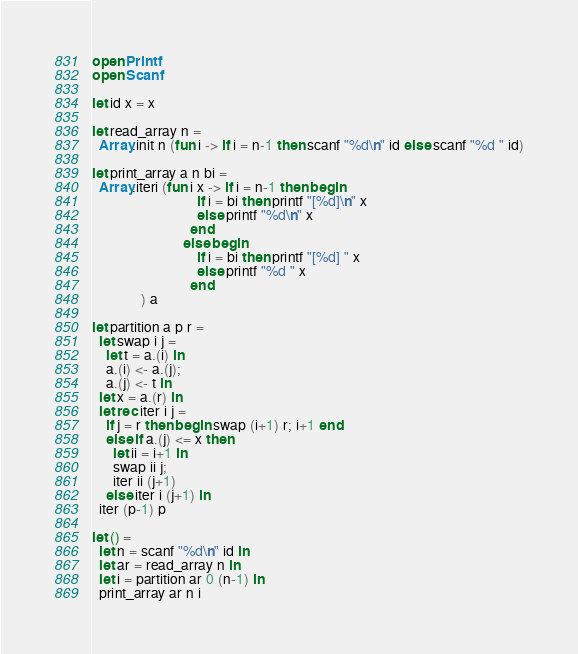<code> <loc_0><loc_0><loc_500><loc_500><_OCaml_>open Printf
open Scanf

let id x = x

let read_array n =
  Array.init n (fun i -> if i = n-1 then scanf "%d\n" id else scanf "%d " id)

let print_array a n bi =
  Array.iteri (fun i x -> if i = n-1 then begin
                              if i = bi then printf "[%d]\n" x
                              else printf "%d\n" x
                            end             
                          else begin
                              if i = bi then printf "[%d] " x
                              else printf "%d " x
                            end
              ) a

let partition a p r =
  let swap i j =
    let t = a.(i) in
    a.(i) <- a.(j);
    a.(j) <- t in
  let x = a.(r) in
  let rec iter i j =
    if j = r then begin swap (i+1) r; i+1 end
    else if a.(j) <= x then
      let ii = i+1 in
      swap ii j;
      iter ii (j+1)
    else iter i (j+1) in
  iter (p-1) p
  
let () =
  let n = scanf "%d\n" id in
  let ar = read_array n in
  let i = partition ar 0 (n-1) in
  print_array ar n i</code> 